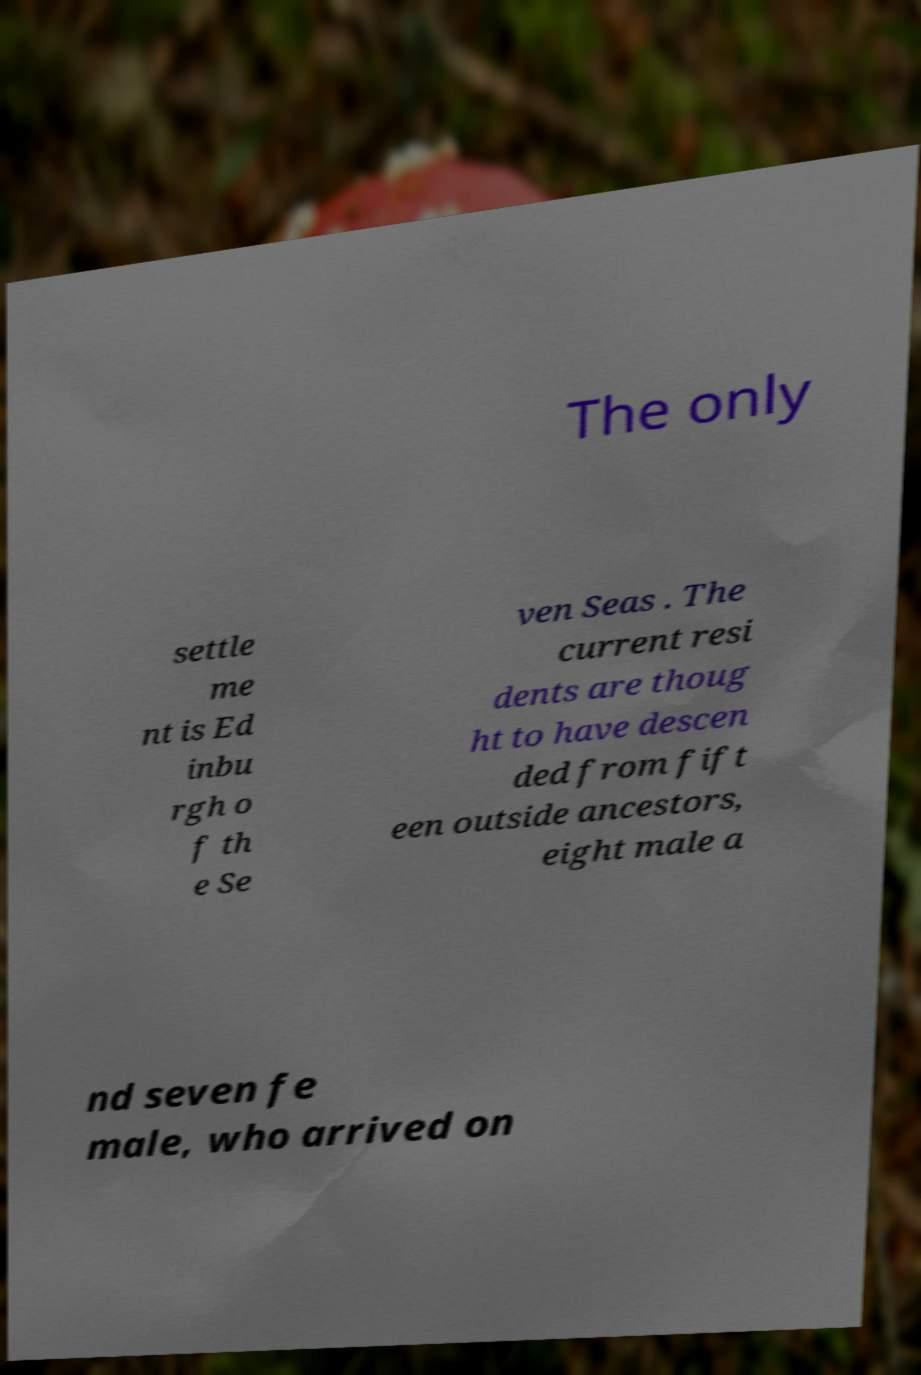I need the written content from this picture converted into text. Can you do that? The only settle me nt is Ed inbu rgh o f th e Se ven Seas . The current resi dents are thoug ht to have descen ded from fift een outside ancestors, eight male a nd seven fe male, who arrived on 